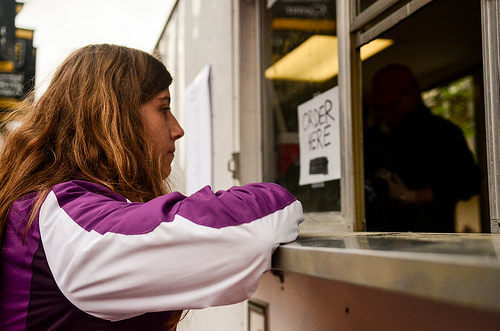<image>
Can you confirm if the woman is next to the cook? Yes. The woman is positioned adjacent to the cook, located nearby in the same general area. 